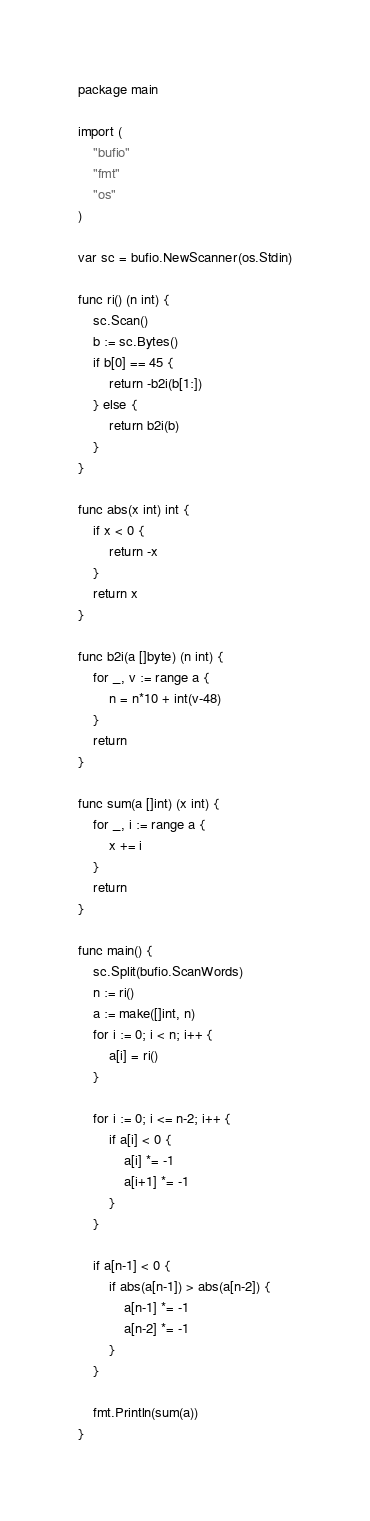Convert code to text. <code><loc_0><loc_0><loc_500><loc_500><_Go_>package main

import (
	"bufio"
	"fmt"
	"os"
)

var sc = bufio.NewScanner(os.Stdin)

func ri() (n int) {
	sc.Scan()
	b := sc.Bytes()
	if b[0] == 45 {
		return -b2i(b[1:])
	} else {
		return b2i(b)
	}
}

func abs(x int) int {
	if x < 0 {
		return -x
	}
	return x
}

func b2i(a []byte) (n int) {
	for _, v := range a {
		n = n*10 + int(v-48)
	}
	return
}

func sum(a []int) (x int) {
	for _, i := range a {
		x += i
	}
	return
}

func main() {
	sc.Split(bufio.ScanWords)
	n := ri()
	a := make([]int, n)
	for i := 0; i < n; i++ {
		a[i] = ri()
	}

	for i := 0; i <= n-2; i++ {
		if a[i] < 0 {
			a[i] *= -1
			a[i+1] *= -1
		}
	}

	if a[n-1] < 0 {
		if abs(a[n-1]) > abs(a[n-2]) {
			a[n-1] *= -1
			a[n-2] *= -1
		}
	}

	fmt.Println(sum(a))
}
</code> 